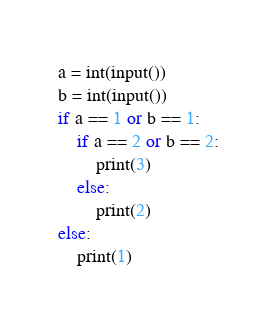<code> <loc_0><loc_0><loc_500><loc_500><_Python_>a = int(input())
b = int(input())
if a == 1 or b == 1:
    if a == 2 or b == 2:
        print(3)
    else:
        print(2)
else:
    print(1)</code> 